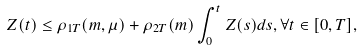Convert formula to latex. <formula><loc_0><loc_0><loc_500><loc_500>Z ( t ) \leq \rho _ { 1 T } ( m , \mu ) + \rho _ { 2 T } ( m ) \int _ { 0 } ^ { t } Z ( s ) d s , \forall t \in [ 0 , T ] ,</formula> 